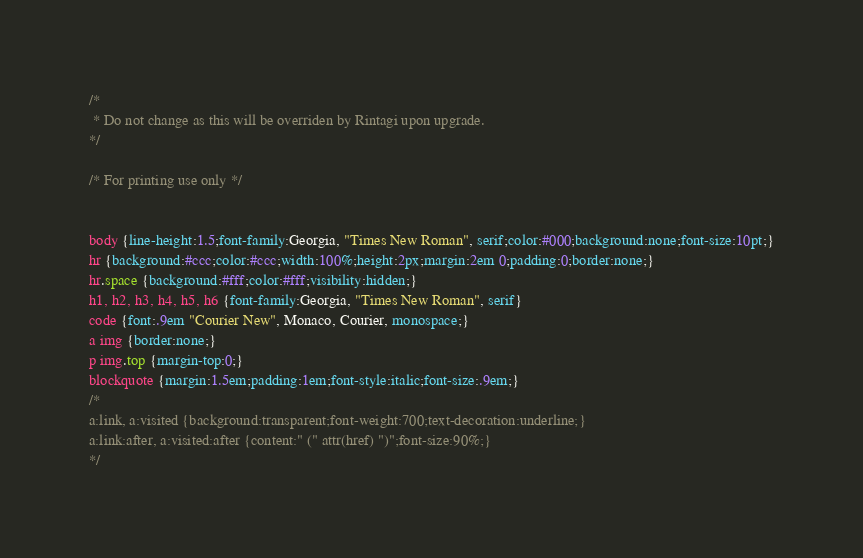Convert code to text. <code><loc_0><loc_0><loc_500><loc_500><_CSS_>/*
 * Do not change as this will be overriden by Rintagi upon upgrade.
*/

/* For printing use only */


body {line-height:1.5;font-family:Georgia, "Times New Roman", serif;color:#000;background:none;font-size:10pt;}
hr {background:#ccc;color:#ccc;width:100%;height:2px;margin:2em 0;padding:0;border:none;}
hr.space {background:#fff;color:#fff;visibility:hidden;}
h1, h2, h3, h4, h5, h6 {font-family:Georgia, "Times New Roman", serif}
code {font:.9em "Courier New", Monaco, Courier, monospace;}
a img {border:none;}
p img.top {margin-top:0;}
blockquote {margin:1.5em;padding:1em;font-style:italic;font-size:.9em;}
/*
a:link, a:visited {background:transparent;font-weight:700;text-decoration:underline;}
a:link:after, a:visited:after {content:" (" attr(href) ")";font-size:90%;}
*/</code> 